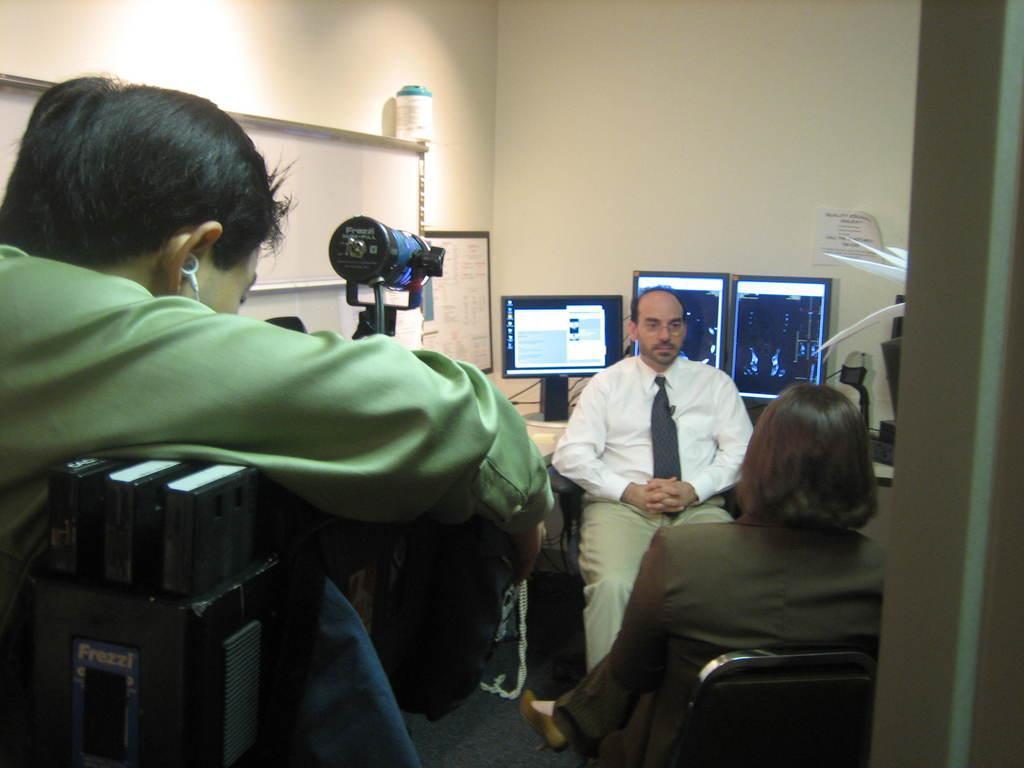In one or two sentences, can you explain what this image depicts? In this picture I can see two persons sitting on the chairs, there is another person, and there are monitors on the table, there are papers to the wall and there are some other items. 